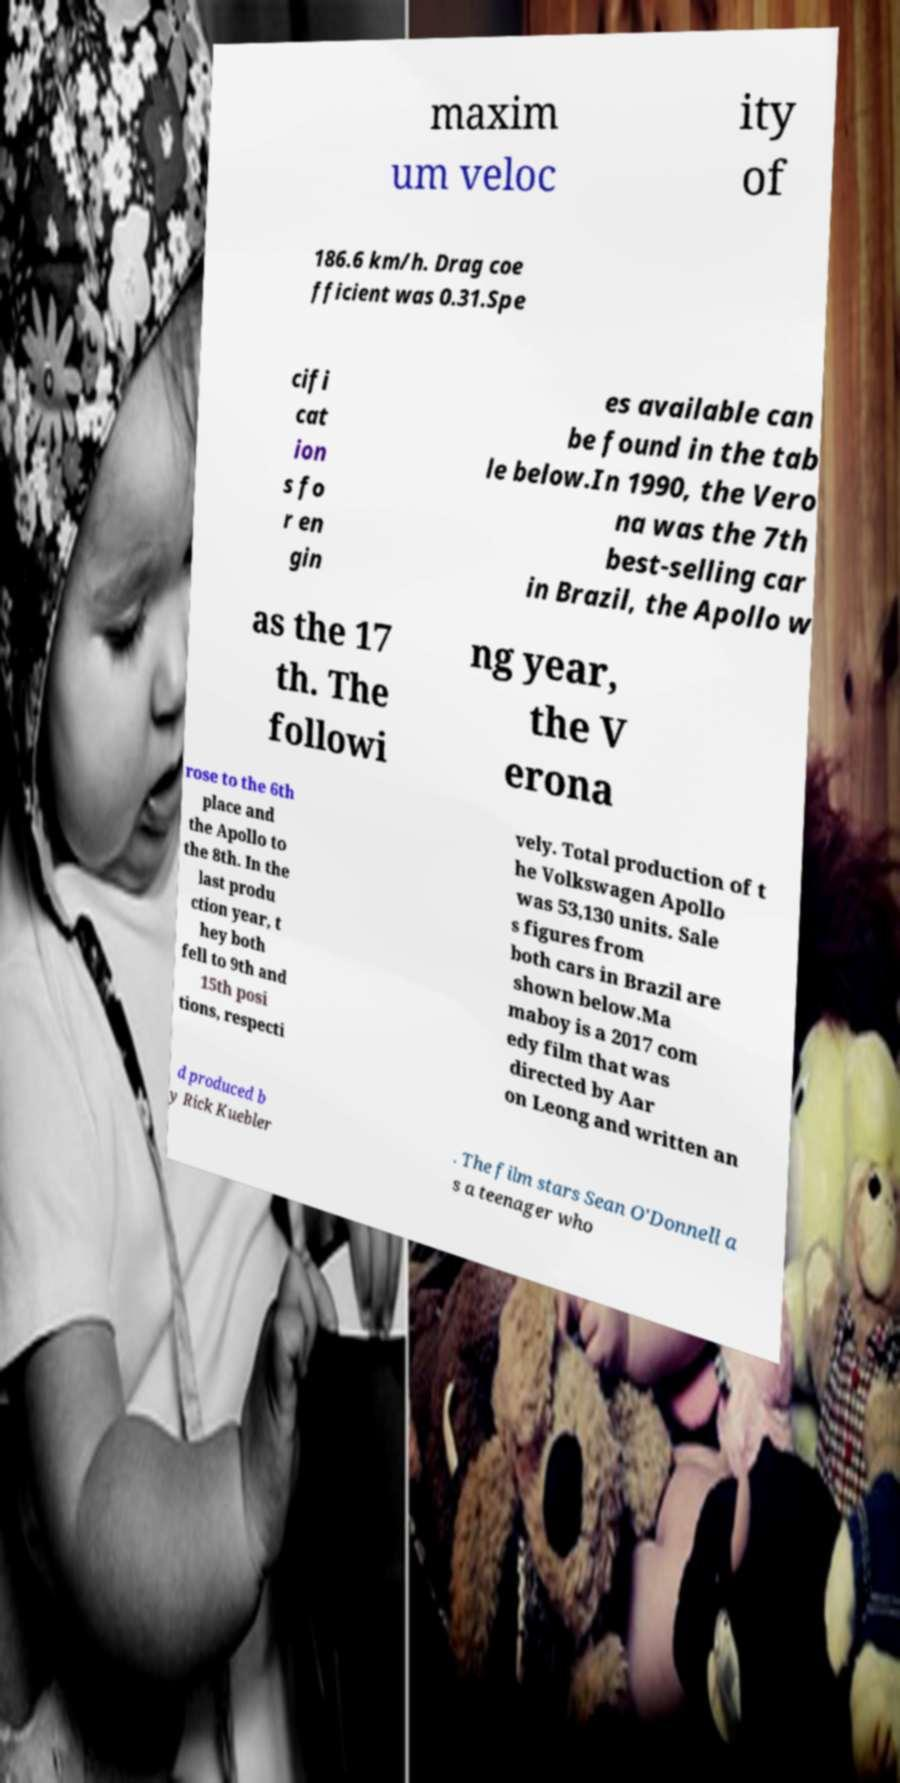I need the written content from this picture converted into text. Can you do that? maxim um veloc ity of 186.6 km/h. Drag coe fficient was 0.31.Spe cifi cat ion s fo r en gin es available can be found in the tab le below.In 1990, the Vero na was the 7th best-selling car in Brazil, the Apollo w as the 17 th. The followi ng year, the V erona rose to the 6th place and the Apollo to the 8th. In the last produ ction year, t hey both fell to 9th and 15th posi tions, respecti vely. Total production of t he Volkswagen Apollo was 53,130 units. Sale s figures from both cars in Brazil are shown below.Ma maboy is a 2017 com edy film that was directed by Aar on Leong and written an d produced b y Rick Kuebler . The film stars Sean O'Donnell a s a teenager who 